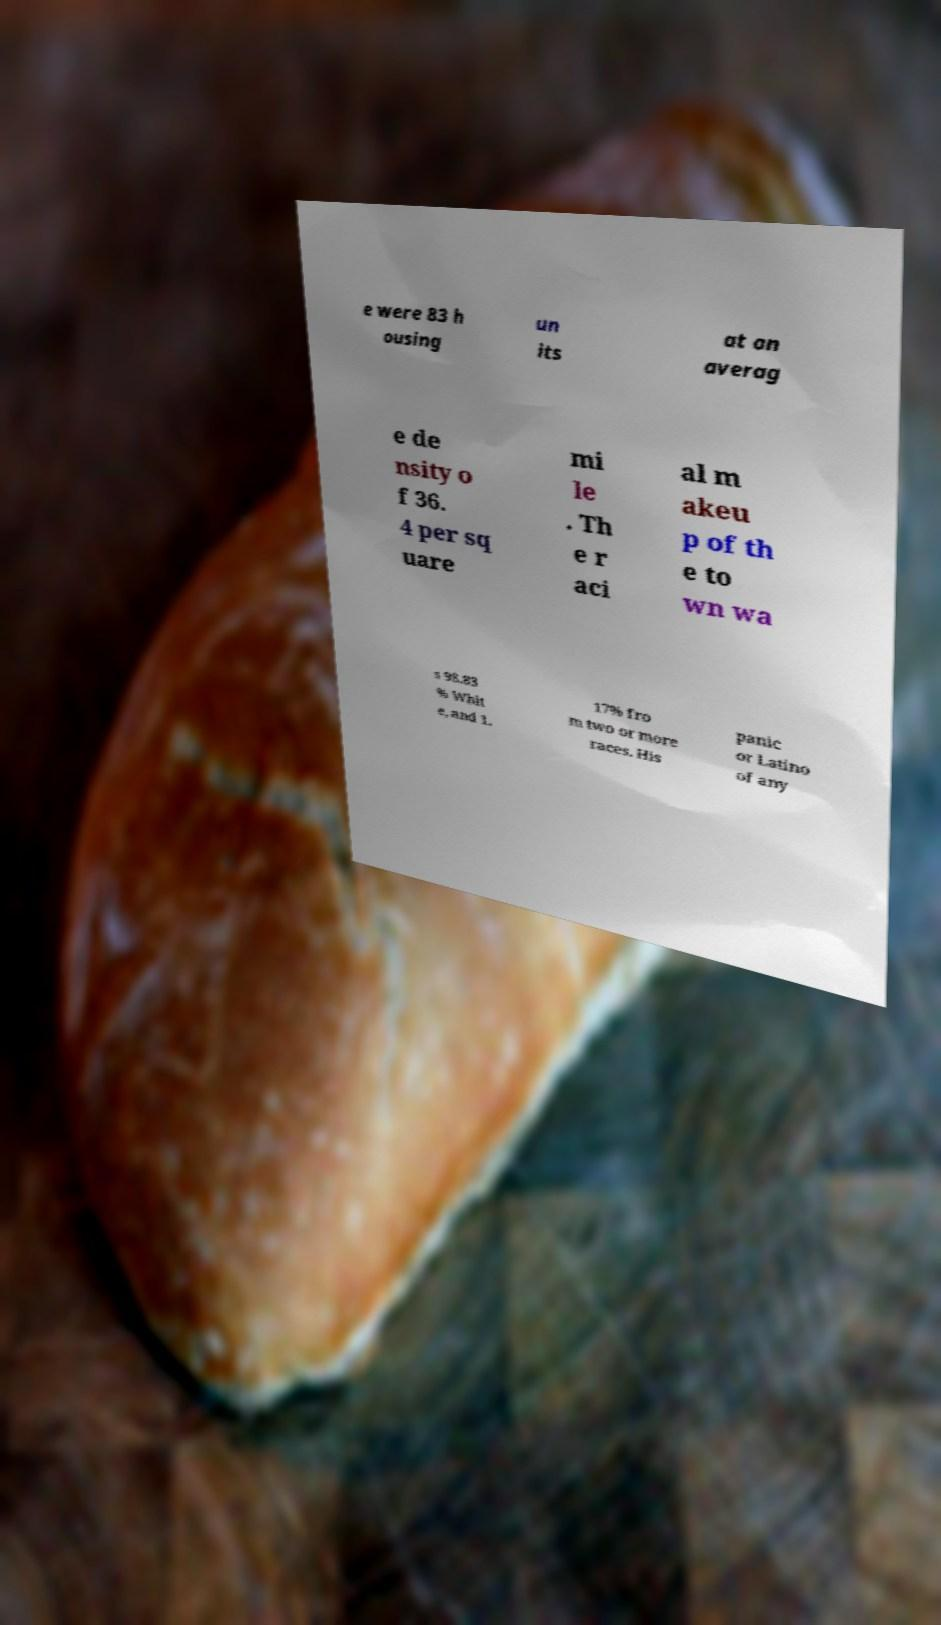For documentation purposes, I need the text within this image transcribed. Could you provide that? e were 83 h ousing un its at an averag e de nsity o f 36. 4 per sq uare mi le . Th e r aci al m akeu p of th e to wn wa s 98.83 % Whit e, and 1. 17% fro m two or more races. His panic or Latino of any 